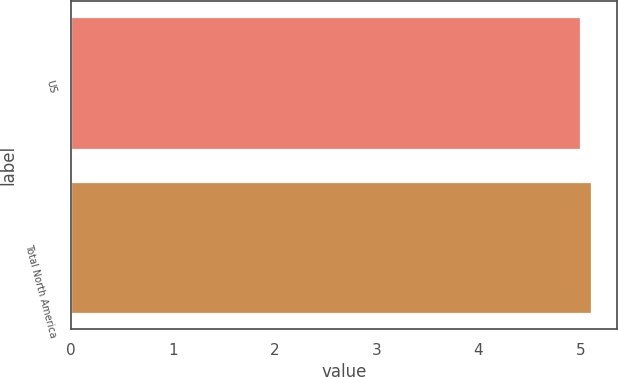Convert chart to OTSL. <chart><loc_0><loc_0><loc_500><loc_500><bar_chart><fcel>US<fcel>Total North America<nl><fcel>5<fcel>5.1<nl></chart> 